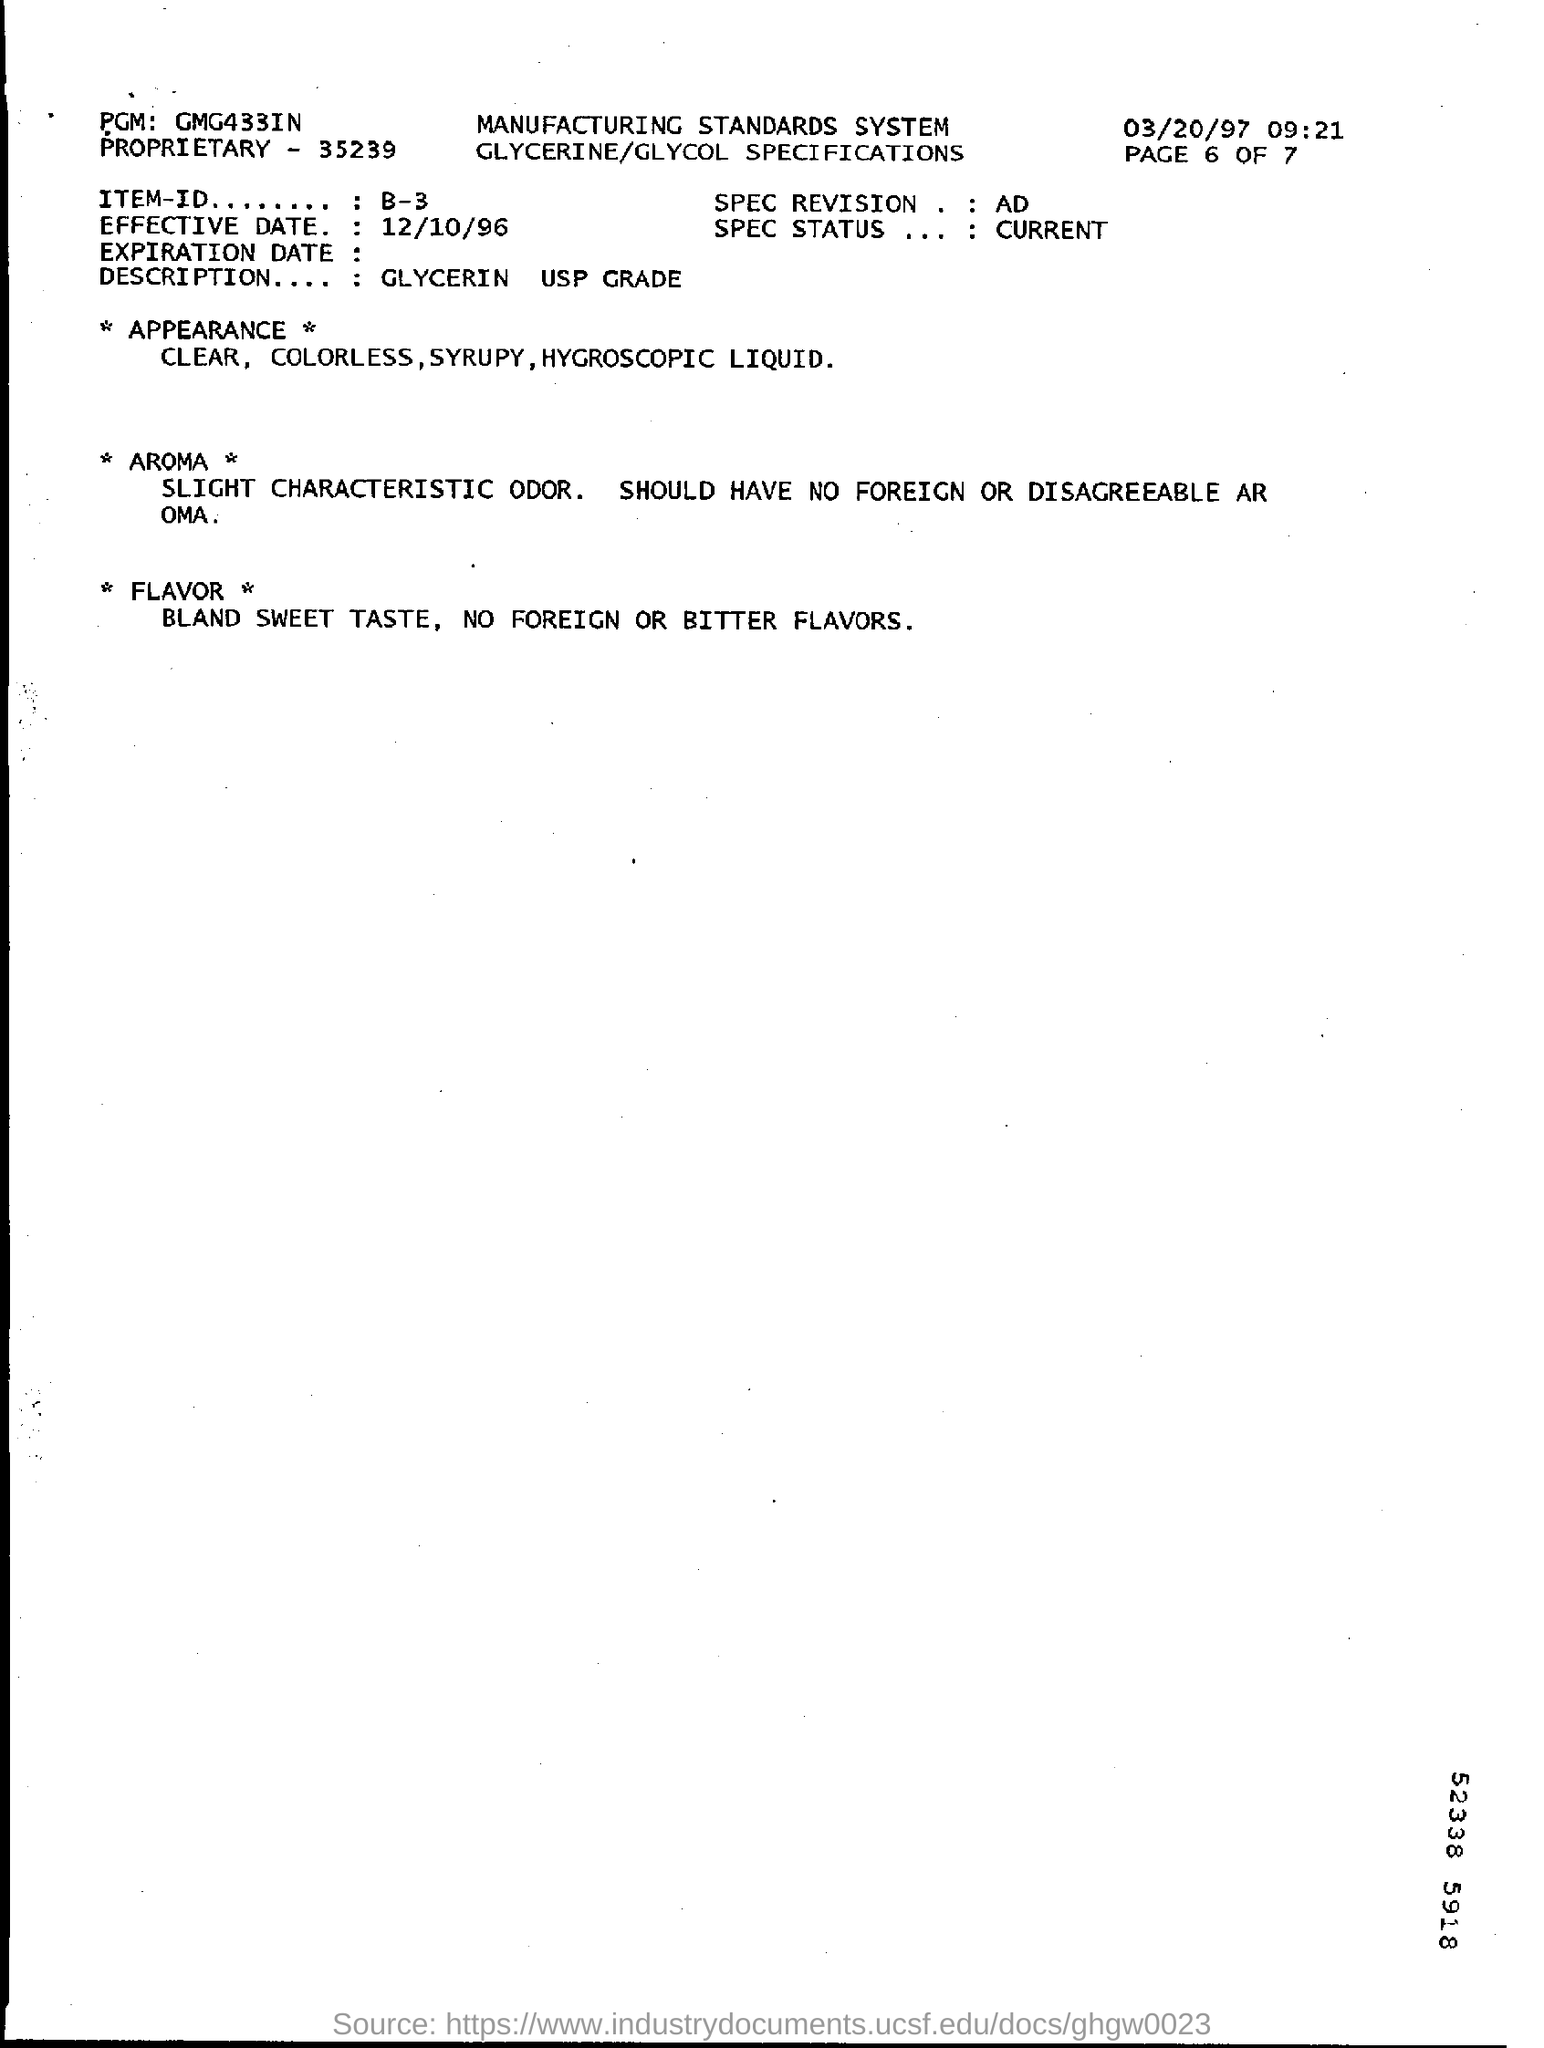Highlight a few significant elements in this photo. The effective date of December 10, 1996, has been established. The date displayed in the top right corner of the document is 03/20/97. The description field contains the text 'GLYCERIN USP GRADE.' The Item-Id field contains information regarding B-3. 